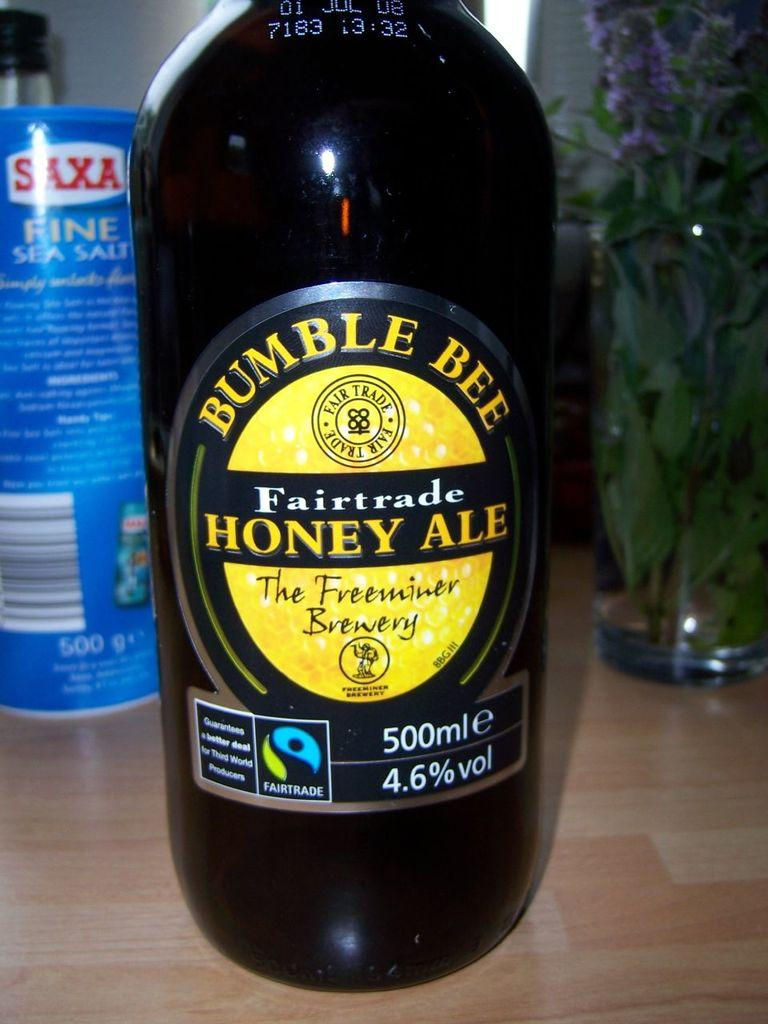<image>
Provide a brief description of the given image. A bottle of honey ale is made by the Freeminer Brewery. 